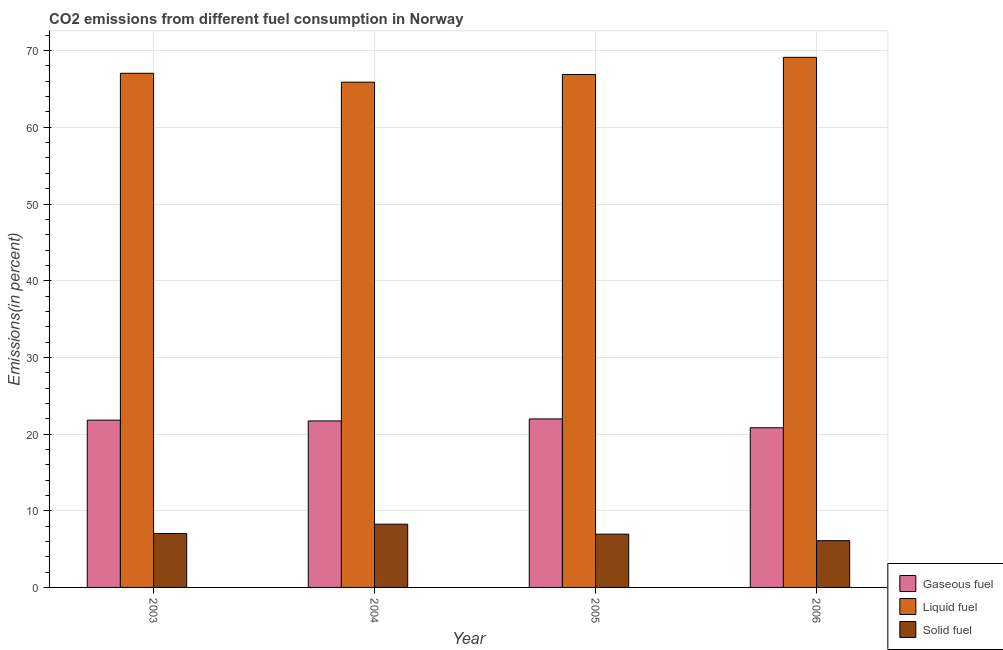How many groups of bars are there?
Provide a short and direct response. 4. Are the number of bars per tick equal to the number of legend labels?
Give a very brief answer. Yes. Are the number of bars on each tick of the X-axis equal?
Provide a short and direct response. Yes. How many bars are there on the 1st tick from the left?
Your answer should be compact. 3. What is the percentage of liquid fuel emission in 2006?
Your answer should be compact. 69.13. Across all years, what is the maximum percentage of liquid fuel emission?
Keep it short and to the point. 69.13. Across all years, what is the minimum percentage of liquid fuel emission?
Your answer should be very brief. 65.89. In which year was the percentage of solid fuel emission maximum?
Provide a succinct answer. 2004. In which year was the percentage of solid fuel emission minimum?
Your response must be concise. 2006. What is the total percentage of solid fuel emission in the graph?
Your response must be concise. 28.32. What is the difference between the percentage of liquid fuel emission in 2003 and that in 2004?
Provide a short and direct response. 1.16. What is the difference between the percentage of solid fuel emission in 2003 and the percentage of gaseous fuel emission in 2004?
Your answer should be very brief. -1.22. What is the average percentage of liquid fuel emission per year?
Provide a short and direct response. 67.24. In the year 2003, what is the difference between the percentage of solid fuel emission and percentage of liquid fuel emission?
Provide a succinct answer. 0. What is the ratio of the percentage of gaseous fuel emission in 2003 to that in 2004?
Your answer should be very brief. 1. Is the percentage of liquid fuel emission in 2004 less than that in 2005?
Provide a succinct answer. Yes. What is the difference between the highest and the second highest percentage of gaseous fuel emission?
Provide a succinct answer. 0.16. What is the difference between the highest and the lowest percentage of liquid fuel emission?
Offer a very short reply. 3.24. What does the 3rd bar from the left in 2004 represents?
Keep it short and to the point. Solid fuel. What does the 2nd bar from the right in 2006 represents?
Your response must be concise. Liquid fuel. How many bars are there?
Ensure brevity in your answer.  12. Are the values on the major ticks of Y-axis written in scientific E-notation?
Your response must be concise. No. Does the graph contain grids?
Offer a terse response. Yes. Where does the legend appear in the graph?
Offer a very short reply. Bottom right. How many legend labels are there?
Ensure brevity in your answer.  3. How are the legend labels stacked?
Your answer should be compact. Vertical. What is the title of the graph?
Offer a terse response. CO2 emissions from different fuel consumption in Norway. Does "Taxes on goods and services" appear as one of the legend labels in the graph?
Give a very brief answer. No. What is the label or title of the X-axis?
Provide a succinct answer. Year. What is the label or title of the Y-axis?
Provide a short and direct response. Emissions(in percent). What is the Emissions(in percent) of Gaseous fuel in 2003?
Provide a short and direct response. 21.81. What is the Emissions(in percent) in Liquid fuel in 2003?
Make the answer very short. 67.05. What is the Emissions(in percent) in Solid fuel in 2003?
Provide a short and direct response. 7.03. What is the Emissions(in percent) of Gaseous fuel in 2004?
Offer a terse response. 21.71. What is the Emissions(in percent) of Liquid fuel in 2004?
Provide a short and direct response. 65.89. What is the Emissions(in percent) in Solid fuel in 2004?
Ensure brevity in your answer.  8.25. What is the Emissions(in percent) of Gaseous fuel in 2005?
Your answer should be compact. 21.97. What is the Emissions(in percent) of Liquid fuel in 2005?
Provide a short and direct response. 66.89. What is the Emissions(in percent) of Solid fuel in 2005?
Provide a short and direct response. 6.95. What is the Emissions(in percent) of Gaseous fuel in 2006?
Keep it short and to the point. 20.82. What is the Emissions(in percent) of Liquid fuel in 2006?
Your answer should be very brief. 69.13. What is the Emissions(in percent) of Solid fuel in 2006?
Your answer should be compact. 6.1. Across all years, what is the maximum Emissions(in percent) of Gaseous fuel?
Offer a terse response. 21.97. Across all years, what is the maximum Emissions(in percent) in Liquid fuel?
Ensure brevity in your answer.  69.13. Across all years, what is the maximum Emissions(in percent) of Solid fuel?
Provide a short and direct response. 8.25. Across all years, what is the minimum Emissions(in percent) in Gaseous fuel?
Provide a succinct answer. 20.82. Across all years, what is the minimum Emissions(in percent) of Liquid fuel?
Your answer should be compact. 65.89. Across all years, what is the minimum Emissions(in percent) in Solid fuel?
Keep it short and to the point. 6.1. What is the total Emissions(in percent) in Gaseous fuel in the graph?
Provide a succinct answer. 86.32. What is the total Emissions(in percent) of Liquid fuel in the graph?
Your answer should be very brief. 268.95. What is the total Emissions(in percent) of Solid fuel in the graph?
Provide a short and direct response. 28.32. What is the difference between the Emissions(in percent) in Gaseous fuel in 2003 and that in 2004?
Ensure brevity in your answer.  0.1. What is the difference between the Emissions(in percent) in Liquid fuel in 2003 and that in 2004?
Your response must be concise. 1.16. What is the difference between the Emissions(in percent) in Solid fuel in 2003 and that in 2004?
Offer a very short reply. -1.22. What is the difference between the Emissions(in percent) of Gaseous fuel in 2003 and that in 2005?
Provide a succinct answer. -0.16. What is the difference between the Emissions(in percent) of Liquid fuel in 2003 and that in 2005?
Offer a terse response. 0.16. What is the difference between the Emissions(in percent) in Solid fuel in 2003 and that in 2005?
Provide a short and direct response. 0.08. What is the difference between the Emissions(in percent) of Gaseous fuel in 2003 and that in 2006?
Ensure brevity in your answer.  0.99. What is the difference between the Emissions(in percent) in Liquid fuel in 2003 and that in 2006?
Offer a terse response. -2.08. What is the difference between the Emissions(in percent) in Solid fuel in 2003 and that in 2006?
Make the answer very short. 0.93. What is the difference between the Emissions(in percent) in Gaseous fuel in 2004 and that in 2005?
Your answer should be very brief. -0.26. What is the difference between the Emissions(in percent) of Liquid fuel in 2004 and that in 2005?
Keep it short and to the point. -1. What is the difference between the Emissions(in percent) of Solid fuel in 2004 and that in 2005?
Give a very brief answer. 1.3. What is the difference between the Emissions(in percent) of Gaseous fuel in 2004 and that in 2006?
Keep it short and to the point. 0.89. What is the difference between the Emissions(in percent) of Liquid fuel in 2004 and that in 2006?
Your response must be concise. -3.24. What is the difference between the Emissions(in percent) of Solid fuel in 2004 and that in 2006?
Provide a succinct answer. 2.15. What is the difference between the Emissions(in percent) in Gaseous fuel in 2005 and that in 2006?
Provide a short and direct response. 1.15. What is the difference between the Emissions(in percent) in Liquid fuel in 2005 and that in 2006?
Offer a very short reply. -2.24. What is the difference between the Emissions(in percent) of Solid fuel in 2005 and that in 2006?
Keep it short and to the point. 0.85. What is the difference between the Emissions(in percent) of Gaseous fuel in 2003 and the Emissions(in percent) of Liquid fuel in 2004?
Provide a succinct answer. -44.08. What is the difference between the Emissions(in percent) in Gaseous fuel in 2003 and the Emissions(in percent) in Solid fuel in 2004?
Provide a short and direct response. 13.57. What is the difference between the Emissions(in percent) in Liquid fuel in 2003 and the Emissions(in percent) in Solid fuel in 2004?
Your response must be concise. 58.8. What is the difference between the Emissions(in percent) of Gaseous fuel in 2003 and the Emissions(in percent) of Liquid fuel in 2005?
Your answer should be very brief. -45.08. What is the difference between the Emissions(in percent) in Gaseous fuel in 2003 and the Emissions(in percent) in Solid fuel in 2005?
Offer a very short reply. 14.87. What is the difference between the Emissions(in percent) in Liquid fuel in 2003 and the Emissions(in percent) in Solid fuel in 2005?
Offer a very short reply. 60.1. What is the difference between the Emissions(in percent) in Gaseous fuel in 2003 and the Emissions(in percent) in Liquid fuel in 2006?
Give a very brief answer. -47.31. What is the difference between the Emissions(in percent) of Gaseous fuel in 2003 and the Emissions(in percent) of Solid fuel in 2006?
Ensure brevity in your answer.  15.71. What is the difference between the Emissions(in percent) of Liquid fuel in 2003 and the Emissions(in percent) of Solid fuel in 2006?
Your answer should be compact. 60.95. What is the difference between the Emissions(in percent) in Gaseous fuel in 2004 and the Emissions(in percent) in Liquid fuel in 2005?
Keep it short and to the point. -45.18. What is the difference between the Emissions(in percent) of Gaseous fuel in 2004 and the Emissions(in percent) of Solid fuel in 2005?
Make the answer very short. 14.76. What is the difference between the Emissions(in percent) of Liquid fuel in 2004 and the Emissions(in percent) of Solid fuel in 2005?
Provide a succinct answer. 58.94. What is the difference between the Emissions(in percent) in Gaseous fuel in 2004 and the Emissions(in percent) in Liquid fuel in 2006?
Offer a very short reply. -47.42. What is the difference between the Emissions(in percent) of Gaseous fuel in 2004 and the Emissions(in percent) of Solid fuel in 2006?
Offer a very short reply. 15.61. What is the difference between the Emissions(in percent) in Liquid fuel in 2004 and the Emissions(in percent) in Solid fuel in 2006?
Offer a very short reply. 59.79. What is the difference between the Emissions(in percent) of Gaseous fuel in 2005 and the Emissions(in percent) of Liquid fuel in 2006?
Offer a terse response. -47.15. What is the difference between the Emissions(in percent) of Gaseous fuel in 2005 and the Emissions(in percent) of Solid fuel in 2006?
Your response must be concise. 15.88. What is the difference between the Emissions(in percent) in Liquid fuel in 2005 and the Emissions(in percent) in Solid fuel in 2006?
Offer a very short reply. 60.79. What is the average Emissions(in percent) of Gaseous fuel per year?
Provide a succinct answer. 21.58. What is the average Emissions(in percent) in Liquid fuel per year?
Offer a terse response. 67.24. What is the average Emissions(in percent) of Solid fuel per year?
Give a very brief answer. 7.08. In the year 2003, what is the difference between the Emissions(in percent) in Gaseous fuel and Emissions(in percent) in Liquid fuel?
Keep it short and to the point. -45.23. In the year 2003, what is the difference between the Emissions(in percent) in Gaseous fuel and Emissions(in percent) in Solid fuel?
Your response must be concise. 14.79. In the year 2003, what is the difference between the Emissions(in percent) in Liquid fuel and Emissions(in percent) in Solid fuel?
Give a very brief answer. 60.02. In the year 2004, what is the difference between the Emissions(in percent) of Gaseous fuel and Emissions(in percent) of Liquid fuel?
Ensure brevity in your answer.  -44.18. In the year 2004, what is the difference between the Emissions(in percent) of Gaseous fuel and Emissions(in percent) of Solid fuel?
Your response must be concise. 13.47. In the year 2004, what is the difference between the Emissions(in percent) in Liquid fuel and Emissions(in percent) in Solid fuel?
Give a very brief answer. 57.64. In the year 2005, what is the difference between the Emissions(in percent) in Gaseous fuel and Emissions(in percent) in Liquid fuel?
Your answer should be very brief. -44.91. In the year 2005, what is the difference between the Emissions(in percent) in Gaseous fuel and Emissions(in percent) in Solid fuel?
Your answer should be compact. 15.03. In the year 2005, what is the difference between the Emissions(in percent) in Liquid fuel and Emissions(in percent) in Solid fuel?
Your response must be concise. 59.94. In the year 2006, what is the difference between the Emissions(in percent) of Gaseous fuel and Emissions(in percent) of Liquid fuel?
Your answer should be very brief. -48.31. In the year 2006, what is the difference between the Emissions(in percent) of Gaseous fuel and Emissions(in percent) of Solid fuel?
Give a very brief answer. 14.72. In the year 2006, what is the difference between the Emissions(in percent) in Liquid fuel and Emissions(in percent) in Solid fuel?
Give a very brief answer. 63.03. What is the ratio of the Emissions(in percent) in Liquid fuel in 2003 to that in 2004?
Offer a very short reply. 1.02. What is the ratio of the Emissions(in percent) in Solid fuel in 2003 to that in 2004?
Your answer should be compact. 0.85. What is the ratio of the Emissions(in percent) of Solid fuel in 2003 to that in 2005?
Your answer should be compact. 1.01. What is the ratio of the Emissions(in percent) of Gaseous fuel in 2003 to that in 2006?
Provide a short and direct response. 1.05. What is the ratio of the Emissions(in percent) of Liquid fuel in 2003 to that in 2006?
Provide a succinct answer. 0.97. What is the ratio of the Emissions(in percent) in Solid fuel in 2003 to that in 2006?
Your response must be concise. 1.15. What is the ratio of the Emissions(in percent) of Gaseous fuel in 2004 to that in 2005?
Give a very brief answer. 0.99. What is the ratio of the Emissions(in percent) in Liquid fuel in 2004 to that in 2005?
Your response must be concise. 0.99. What is the ratio of the Emissions(in percent) of Solid fuel in 2004 to that in 2005?
Provide a short and direct response. 1.19. What is the ratio of the Emissions(in percent) of Gaseous fuel in 2004 to that in 2006?
Your answer should be very brief. 1.04. What is the ratio of the Emissions(in percent) in Liquid fuel in 2004 to that in 2006?
Ensure brevity in your answer.  0.95. What is the ratio of the Emissions(in percent) in Solid fuel in 2004 to that in 2006?
Provide a succinct answer. 1.35. What is the ratio of the Emissions(in percent) of Gaseous fuel in 2005 to that in 2006?
Provide a succinct answer. 1.06. What is the ratio of the Emissions(in percent) in Liquid fuel in 2005 to that in 2006?
Offer a terse response. 0.97. What is the ratio of the Emissions(in percent) of Solid fuel in 2005 to that in 2006?
Keep it short and to the point. 1.14. What is the difference between the highest and the second highest Emissions(in percent) in Gaseous fuel?
Your response must be concise. 0.16. What is the difference between the highest and the second highest Emissions(in percent) of Liquid fuel?
Give a very brief answer. 2.08. What is the difference between the highest and the second highest Emissions(in percent) of Solid fuel?
Your answer should be compact. 1.22. What is the difference between the highest and the lowest Emissions(in percent) in Gaseous fuel?
Offer a very short reply. 1.15. What is the difference between the highest and the lowest Emissions(in percent) of Liquid fuel?
Your answer should be compact. 3.24. What is the difference between the highest and the lowest Emissions(in percent) in Solid fuel?
Offer a terse response. 2.15. 